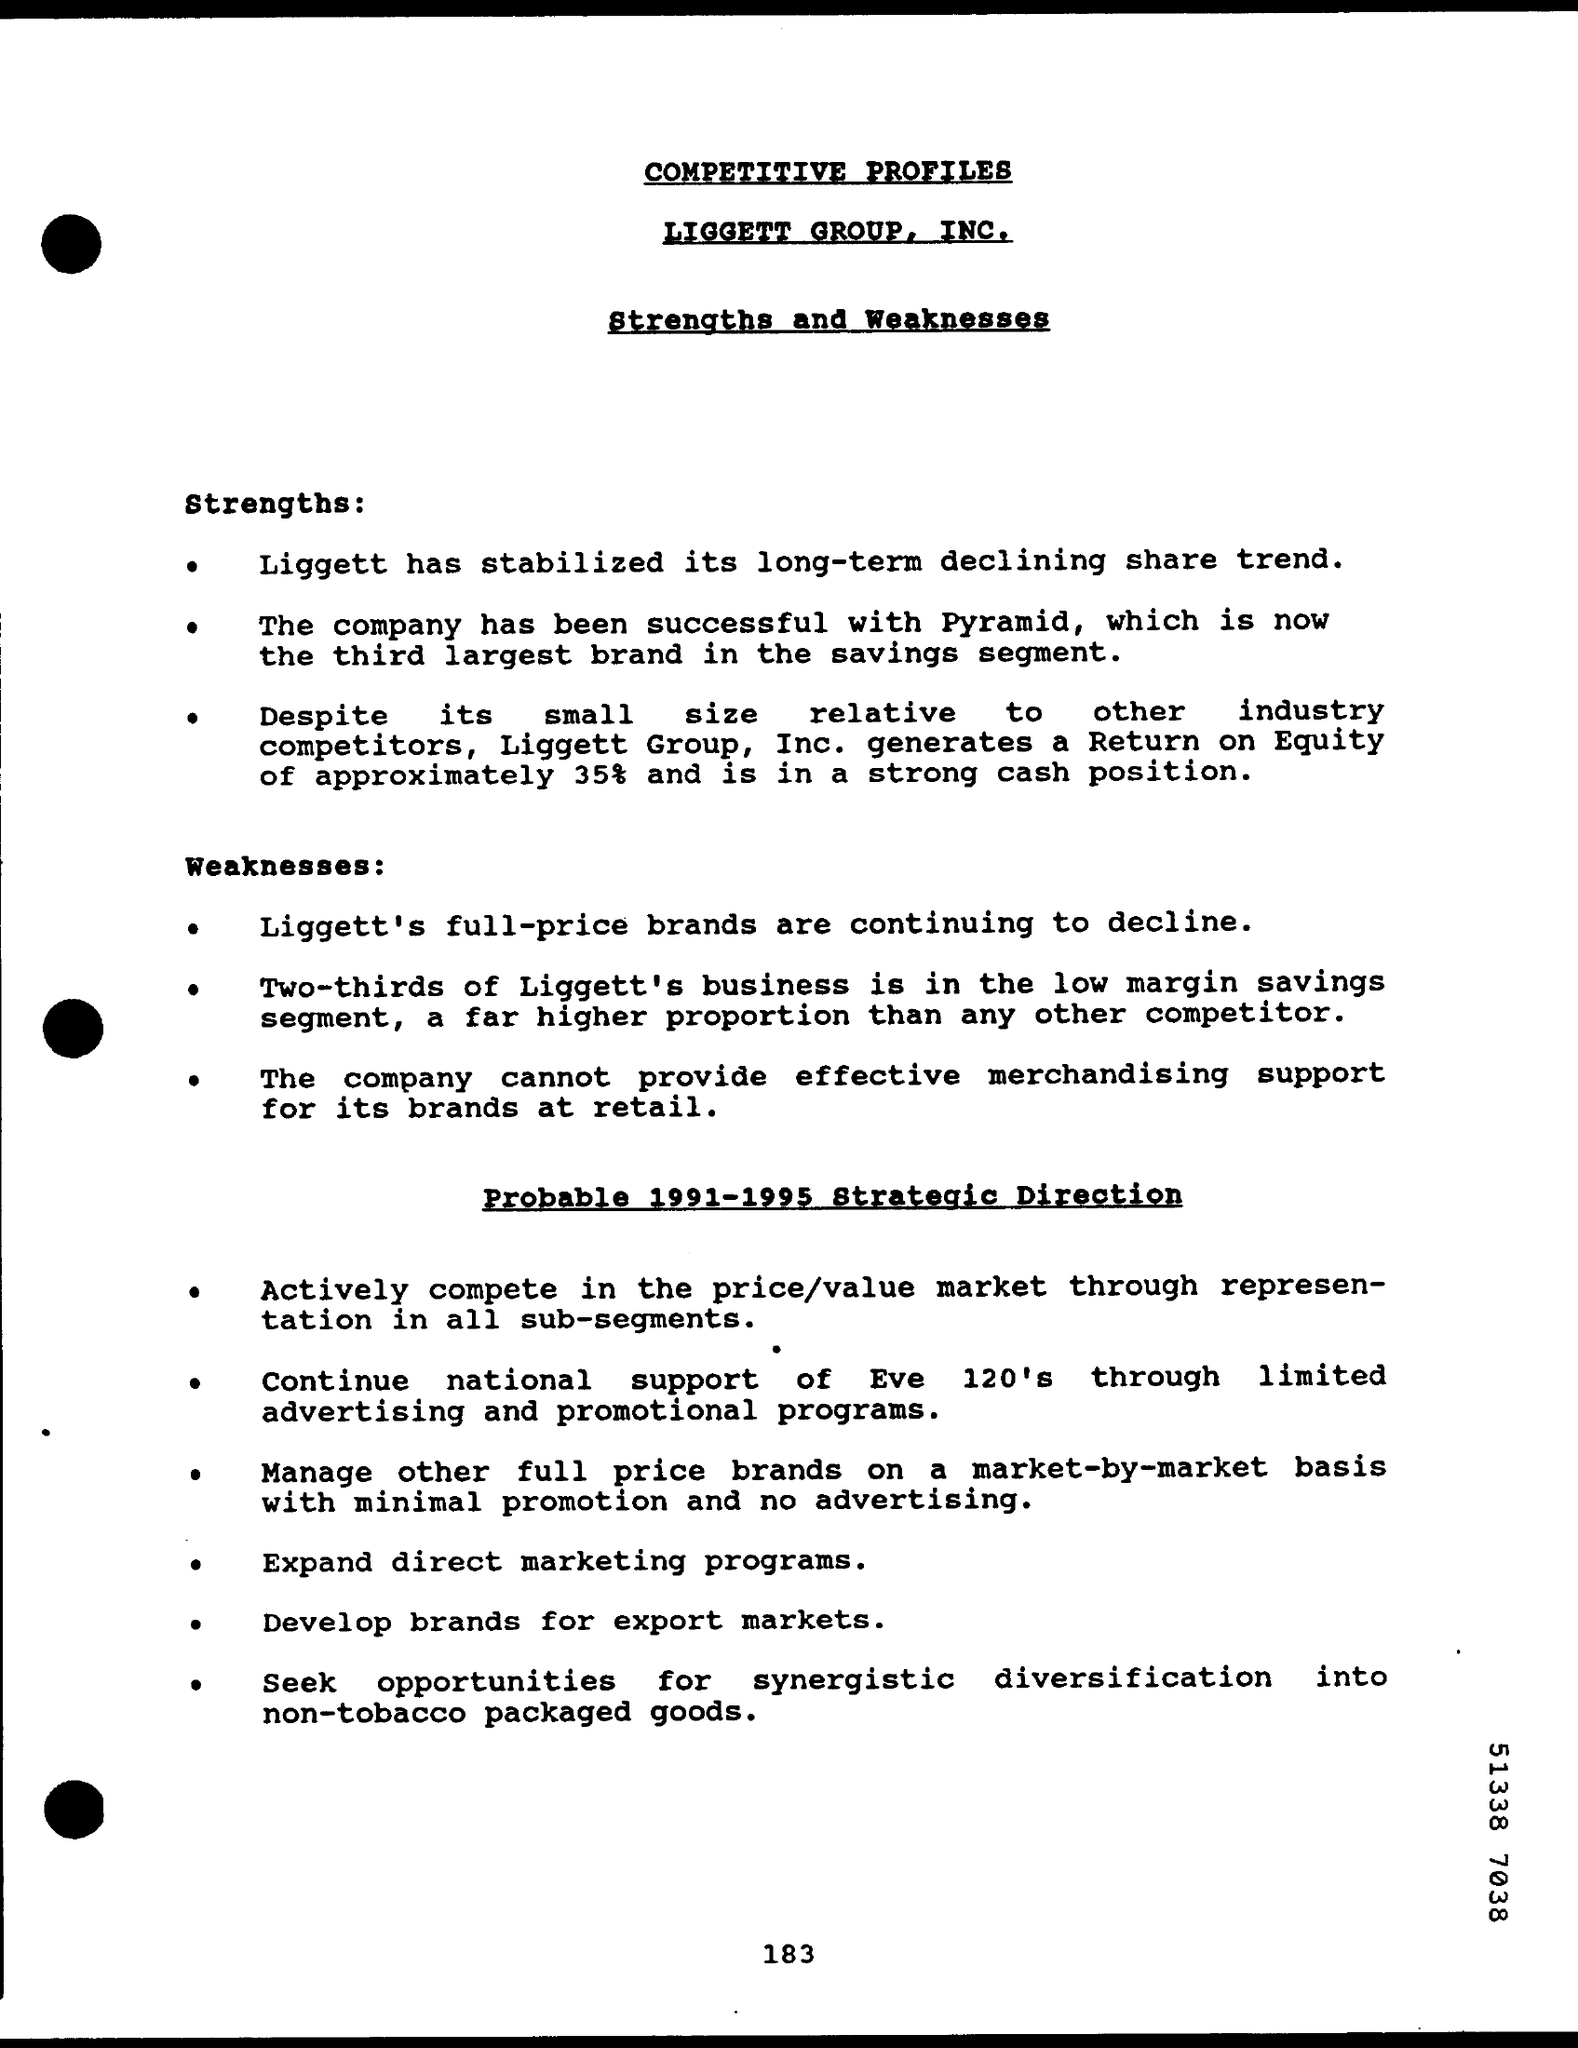Mention the heading written under "LIGGETT GROUP, INC."?
Offer a very short reply. Strengths and Weaknesses. Which "is now the third largest brand in the savings segment"?
Keep it short and to the point. Pyramid. "Two-thirds of Liggett's business is in" which segment?
Your answer should be very brief. Low margin savings segment. What is the page number given at the bottom of the page?
Make the answer very short. 183. What is the first side heading given?
Make the answer very short. Strengths. What is the second side heading given?
Offer a terse response. Weaknesses. 